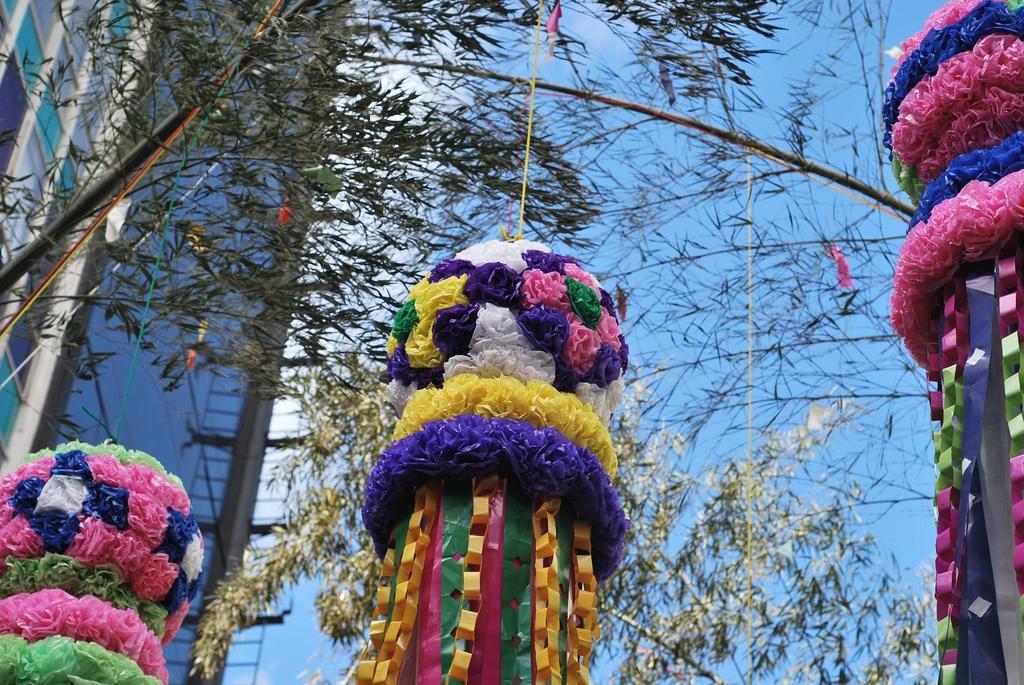Please provide a concise description of this image. In this image we can see the decorative items tied to a tree. In the background, we can see a building and sky. 